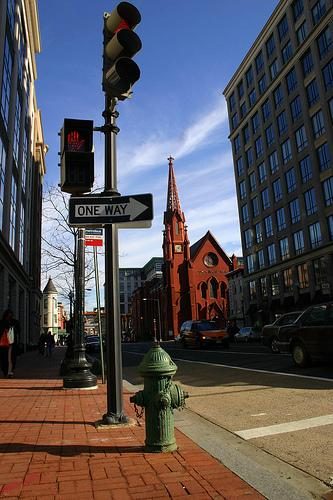What type of object is predominantly green in color and can be found on the sidewalk in the image? A green fire hydrant can be found on the sidewalk in the image. Provide a brief description of the people present in the image along with their observable actions. People walking on the sidewalk can be seen, and one person is holding a red and a white bag. Evaluate the image sentiment and describe the overall atmosphere portrayed by the scene. The image sentiment is neutral, depicting a typical urban scene with people, vehicles, and architectural structures. List the objects related to transportation that can be seen in the image. An orange van, a one-way street sign, a traffic light, a right turn signal on the van, and an orange taxi are present. Mention one traffic control device present in the image and describe its state or function. A traffic light on a black pole is present, and it displays a red signal. Can you elaborate on the appearance of the sidewalk and the materials used for it? The sidewalk is made of red brick and has a fire hydrant, people walking, and a sign on it. Assess the image quality by identifying any discrepancies in the object sizes and positions. The image quality seems appropriate, with varying object sizes and positions, accurately representing a real-life urban landscape. Analyze any interaction between objects within the image and explain them concisely. The interaction includes people walking on the red brick sidewalk with a green fire hydrant, vehicles on the street with a traffic light, and a church alongside them. Identify the notable architectural structure in the image and describe it briefly. A red brick church with a tall steeple and a clock on the tower is featured in the image. Is there an unusual or unexpected object in the image? No, all objects are typical for a street scene. Describe the material of the sidewalk. red brick What type of sign is located behind the one-way sign? black and white sign Identify the tall oak tree beside the red brick church. No, it's not mentioned in the image. Is there a clock visible in the image? If so, where is it located? Yes, on the church steeple. Tell me the feature that distinguishes the cars on the street. They are driving. What color is the fire hydrant? green What type of sign is next to the traffic light? do not walk indicator Is there anything peculiar about the church tower? It has a clock. How many people are seen walking on the sidewalk? 2 What type of car can be seen in the street? orange minivan Identify the type of sidewalk in the image. red brick sidewalk Find three signs in the image. one-way traffic sign, do not walk indicator, black and white sign What objects can be found on the street? white lines, orange van, and three cars driving What color is the traffic light? red What emotions does the image evoke? Neutral, calm, orderly Evaluate the quality of the image. High quality with clear objects and details List any two visible objects in the image. green fire hydrant, red brick church What is the woman holding? A white bag and a red bag 